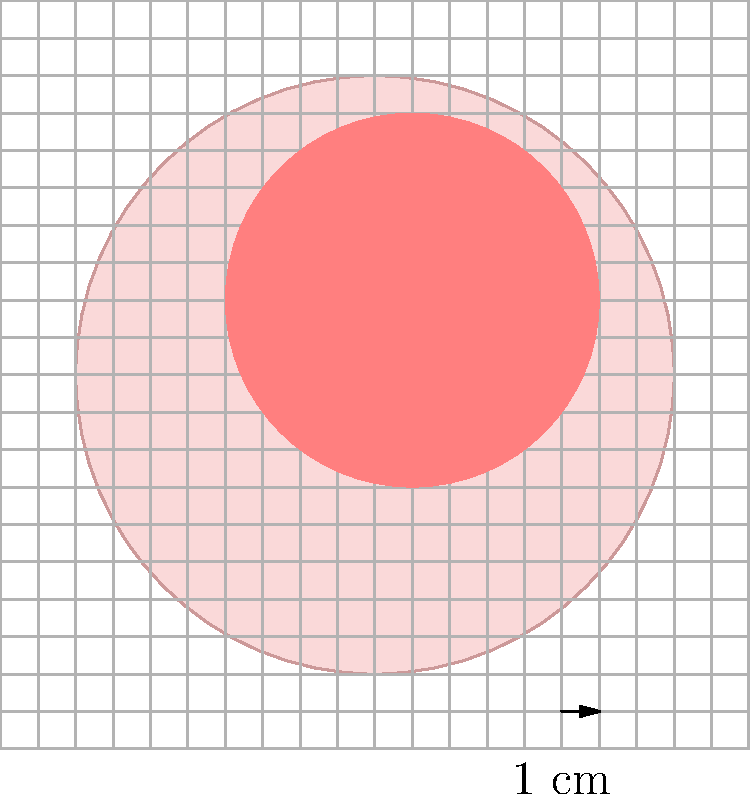A retired physician has diagnosed you with a skin condition and wants to monitor the size of the rash. Using the grid overlay on the skin illustration, where each grid square represents 1 cm², estimate the area of the rash to the nearest whole number. What is the approximate area of the rash in cm²? To estimate the area of the rash, we'll follow these steps:

1. Count the number of whole squares covered by the rash.
2. Estimate the fraction of partially covered squares.
3. Add these numbers together.

Step 1: Counting whole squares
There are approximately 4 whole squares completely covered by the rash.

Step 2: Estimating partial squares
Around the edges of the rash, there are about 8 partially covered squares. We can estimate that on average, these squares are about half covered.

So, the partial squares contribute: $8 \times 0.5 = 4$ square units

Step 3: Adding the whole and partial areas
Total area $\approx$ Whole squares + Partial squares
$\approx 4 + 4 = 8$ cm²

Rounding to the nearest whole number, our estimate remains 8 cm².

This method of estimation is particularly useful when exact measurements aren't possible or necessary, which is often the case in informal medical settings without specialized equipment.
Answer: 8 cm² 